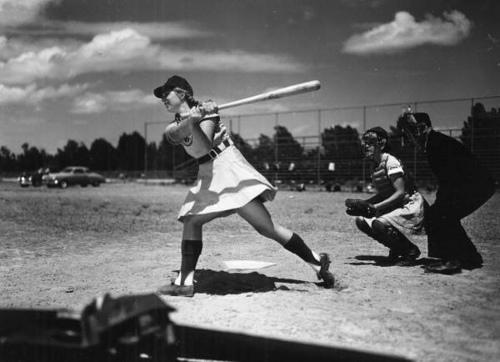Is the batter in uniform?
Concise answer only. Yes. What is she holding?
Keep it brief. Bat. Why is the ground white?
Be succinct. Sun. Are these female baseball players?
Answer briefly. Yes. What kind of ground is this?
Short answer required. Dirt. Are the girl's eyes opened?
Keep it brief. Yes. What is taking place with the people?
Keep it brief. Playing baseball. Was this taken in the United States?
Quick response, please. Yes. What kind of uniform is the lady wearing?
Concise answer only. Baseball. Is this a man or a woman?
Keep it brief. Woman. Can she play with these shoes?
Answer briefly. Yes. What is the woman listening to?
Answer briefly. Coach. What is the person doing kneeling?
Write a very short answer. Catching. What sport does she play?
Answer briefly. Baseball. Is he on the ground?
Answer briefly. Yes. What season is it based on the state of the trees in the background?
Quick response, please. Summer. What sport is being played?
Write a very short answer. Baseball. What are the children doing?
Be succinct. Playing baseball. What is the person standing behind?
Give a very brief answer. Catcher. What activity are they doing?
Quick response, please. Baseball. What is this woman doing?
Quick response, please. Playing baseball. What year was this?
Answer briefly. 1950. What object are the people trying to catch?
Answer briefly. Baseball. What tool is in the right hand?
Give a very brief answer. Bat. What is the person doing?
Be succinct. Playing baseball. What kind of hat is he wearing?
Be succinct. Baseball. Is the lady feeling cold?
Short answer required. No. What kind of pants is the person wearing?
Quick response, please. Skirt. What is this girl's hobby?
Short answer required. Baseball. Did the batter hit the ball?
Give a very brief answer. Yes. What game is being played?
Quick response, please. Baseball. Is the umpire wearing a tie?
Give a very brief answer. No. What is the woman holding in her hands?
Be succinct. Baseball bat. 